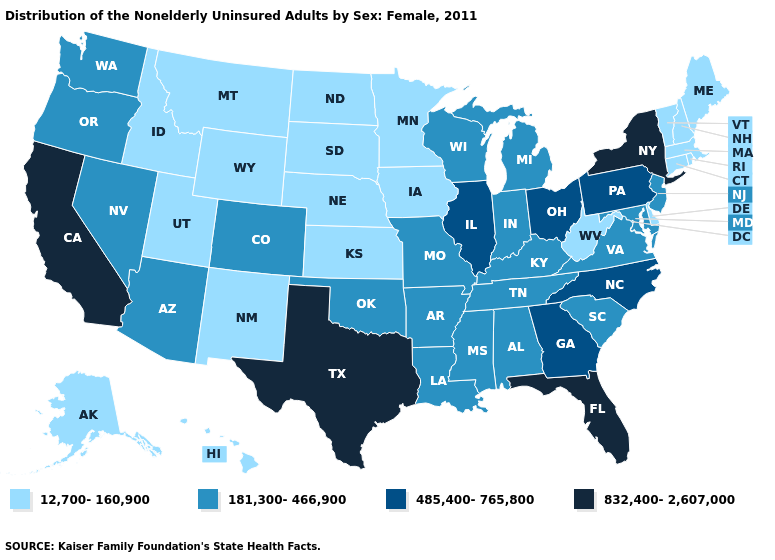Name the states that have a value in the range 832,400-2,607,000?
Short answer required. California, Florida, New York, Texas. What is the value of Massachusetts?
Concise answer only. 12,700-160,900. What is the value of North Dakota?
Give a very brief answer. 12,700-160,900. What is the lowest value in the USA?
Short answer required. 12,700-160,900. Does South Dakota have the lowest value in the USA?
Keep it brief. Yes. Name the states that have a value in the range 181,300-466,900?
Write a very short answer. Alabama, Arizona, Arkansas, Colorado, Indiana, Kentucky, Louisiana, Maryland, Michigan, Mississippi, Missouri, Nevada, New Jersey, Oklahoma, Oregon, South Carolina, Tennessee, Virginia, Washington, Wisconsin. What is the lowest value in states that border Minnesota?
Be succinct. 12,700-160,900. Name the states that have a value in the range 832,400-2,607,000?
Concise answer only. California, Florida, New York, Texas. What is the value of Delaware?
Write a very short answer. 12,700-160,900. Among the states that border New Jersey , does Delaware have the lowest value?
Quick response, please. Yes. Does West Virginia have a lower value than Kentucky?
Be succinct. Yes. Among the states that border Wisconsin , which have the lowest value?
Quick response, please. Iowa, Minnesota. Among the states that border Vermont , does New York have the lowest value?
Short answer required. No. Which states hav the highest value in the MidWest?
Write a very short answer. Illinois, Ohio. What is the value of Texas?
Quick response, please. 832,400-2,607,000. 